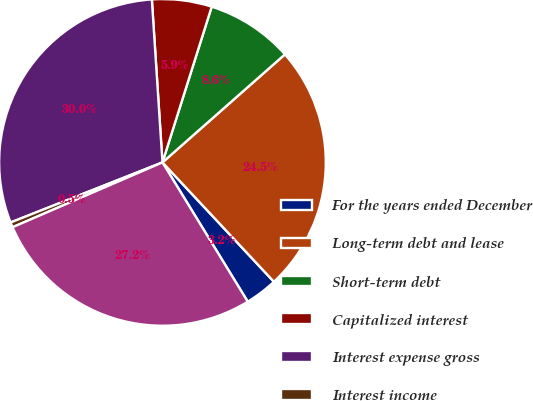<chart> <loc_0><loc_0><loc_500><loc_500><pie_chart><fcel>For the years ended December<fcel>Long-term debt and lease<fcel>Short-term debt<fcel>Capitalized interest<fcel>Interest expense gross<fcel>Interest income<fcel>Interest expense net<nl><fcel>3.21%<fcel>24.55%<fcel>8.62%<fcel>5.91%<fcel>29.96%<fcel>0.5%<fcel>27.25%<nl></chart> 